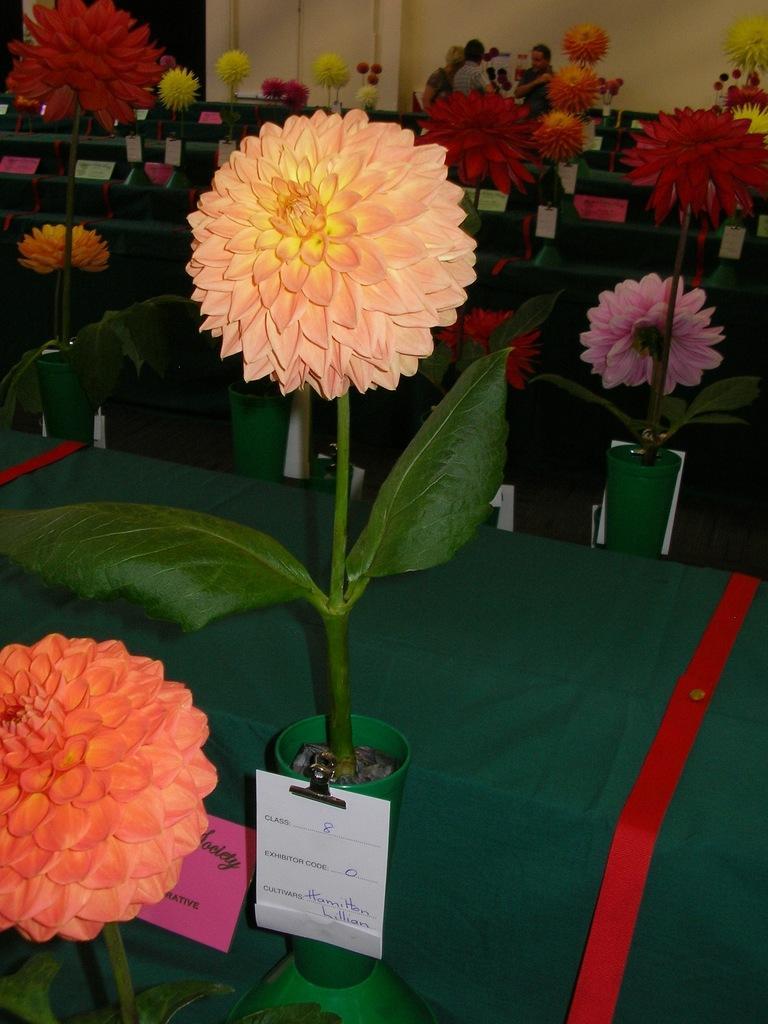Describe this image in one or two sentences. In this image I can see flowers on a green color surface. In the background I can see people and a wall. 